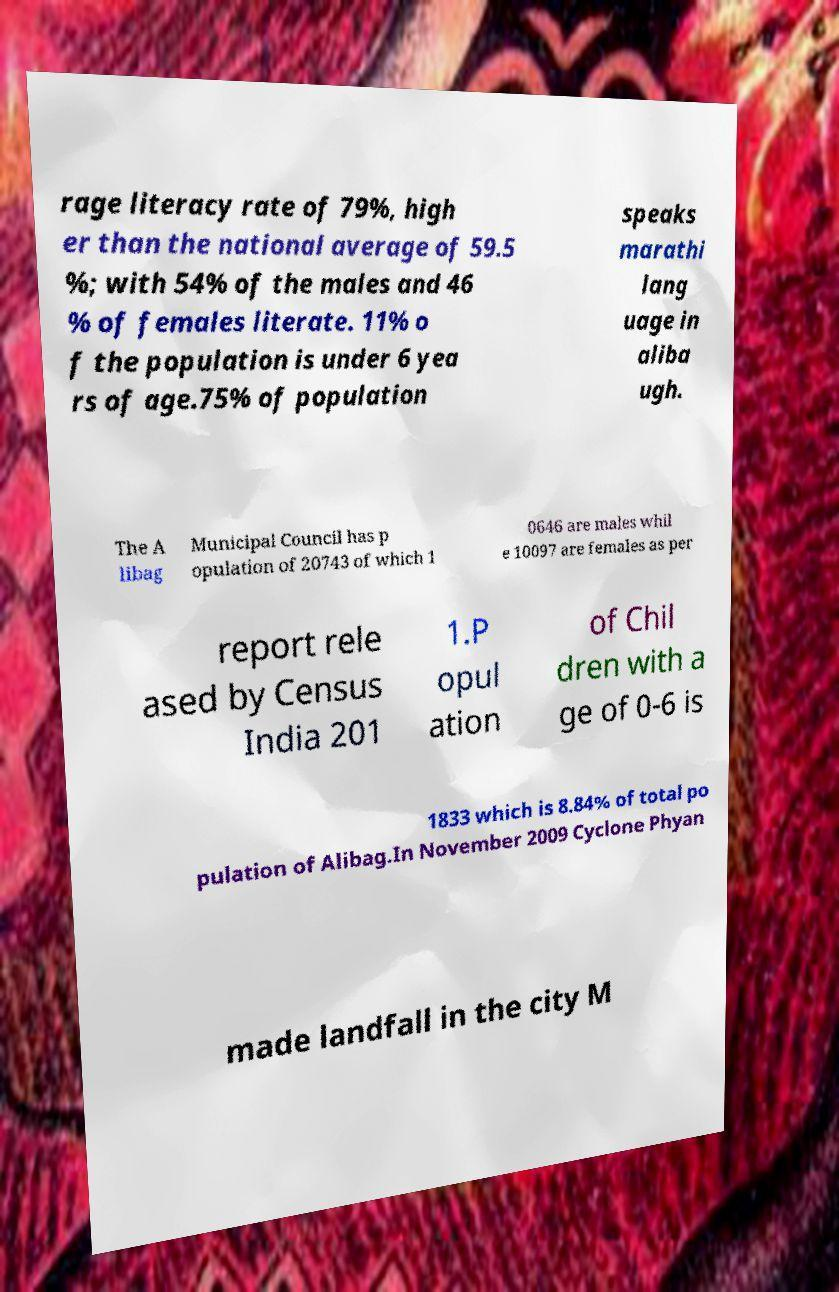Could you assist in decoding the text presented in this image and type it out clearly? rage literacy rate of 79%, high er than the national average of 59.5 %; with 54% of the males and 46 % of females literate. 11% o f the population is under 6 yea rs of age.75% of population speaks marathi lang uage in aliba ugh. The A libag Municipal Council has p opulation of 20743 of which 1 0646 are males whil e 10097 are females as per report rele ased by Census India 201 1.P opul ation of Chil dren with a ge of 0-6 is 1833 which is 8.84% of total po pulation of Alibag.In November 2009 Cyclone Phyan made landfall in the city M 